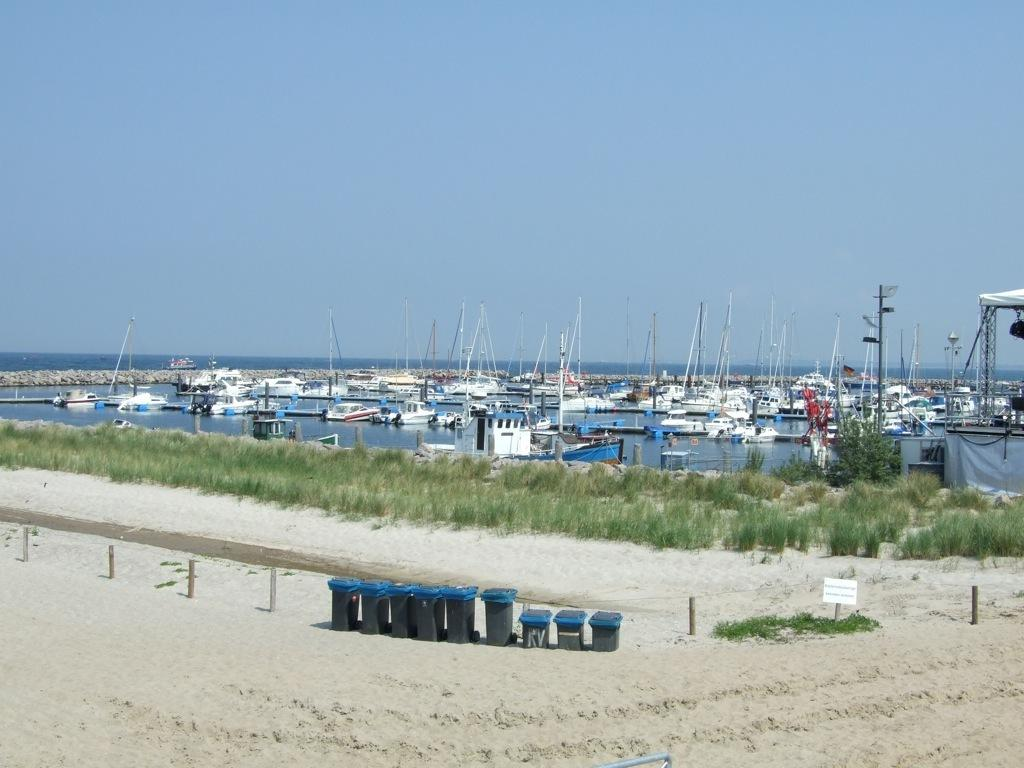What objects can be seen on the sand in the image? There are dust bins on the sand in the image. What structures are present in the image? There are poles and a board in the image. What type of vehicles are on the water in the image? There are boats on the water in the image. What type of vegetation is present in the image? There are plants in the image. What is visible in the background of the image? The sky is visible in the background of the image. How many pizzas are being served by the creator in the image? There are no pizzas or creators present in the image. What type of grape is growing on the plants in the image? There are no grapes visible in the image; only plants are present. 